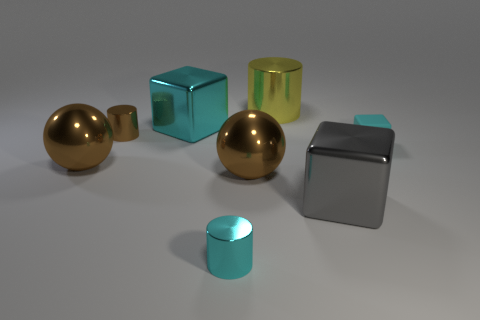Can you describe the colors and shapes of the objects in the image? Certainly! There are two spherical objects, one large brown and one small cyan; two cubes, one large cyan and one smaller yellow with a metallic sheen; and two cylinders, a smaller shiny one and a larger silver one, all resting on a flat surface. 